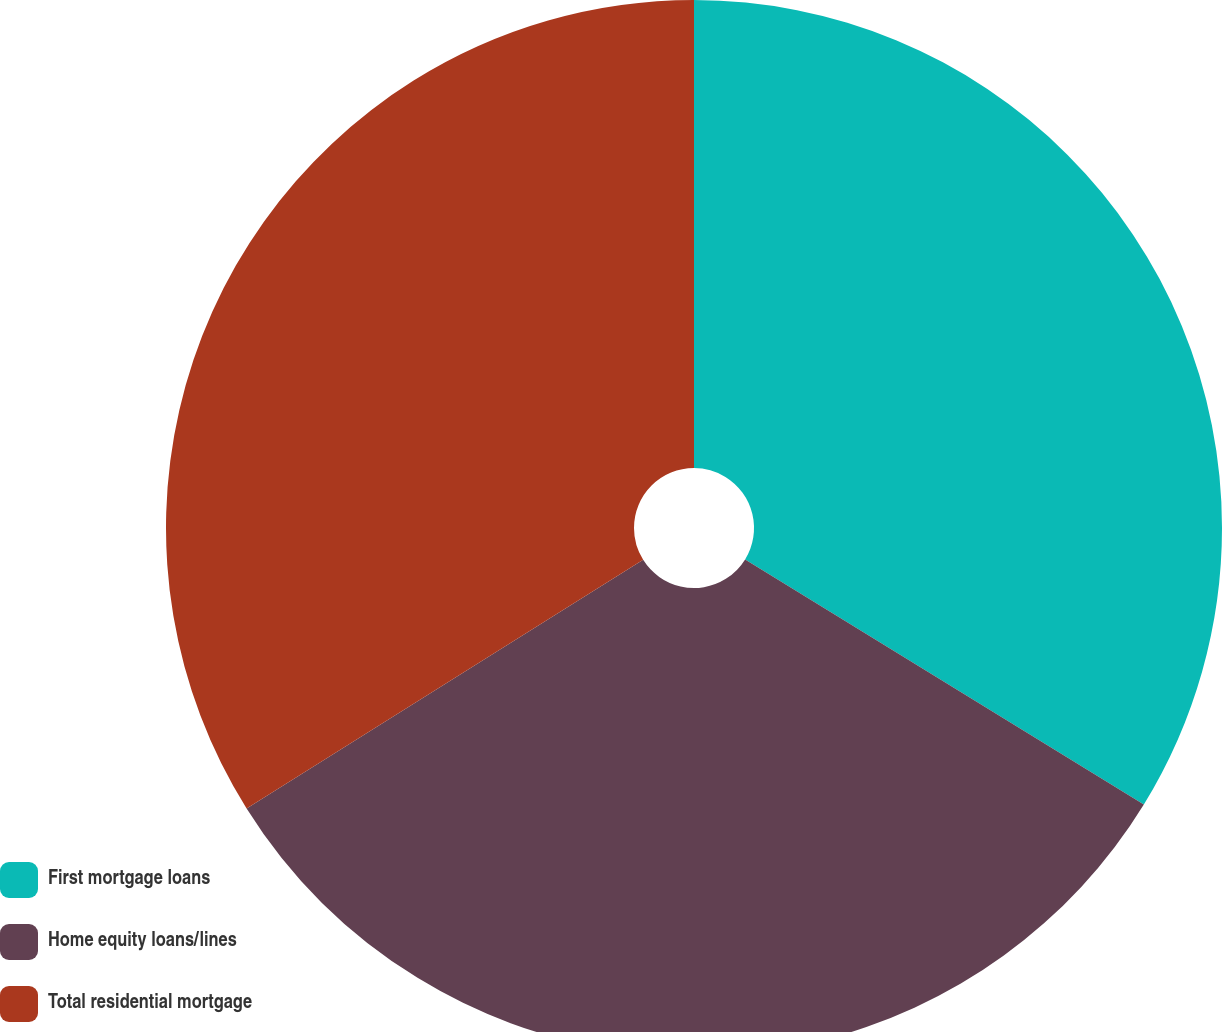Convert chart to OTSL. <chart><loc_0><loc_0><loc_500><loc_500><pie_chart><fcel>First mortgage loans<fcel>Home equity loans/lines<fcel>Total residential mortgage<nl><fcel>33.77%<fcel>32.32%<fcel>33.91%<nl></chart> 